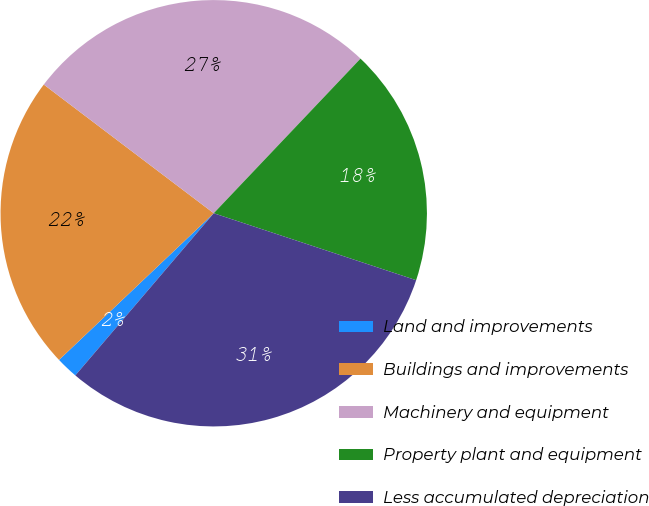Convert chart to OTSL. <chart><loc_0><loc_0><loc_500><loc_500><pie_chart><fcel>Land and improvements<fcel>Buildings and improvements<fcel>Machinery and equipment<fcel>Property plant and equipment<fcel>Less accumulated depreciation<nl><fcel>1.68%<fcel>22.39%<fcel>26.77%<fcel>18.0%<fcel>31.16%<nl></chart> 